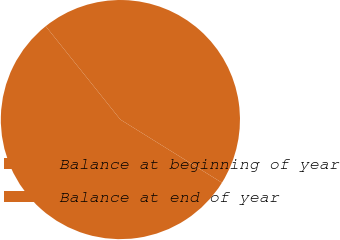Convert chart to OTSL. <chart><loc_0><loc_0><loc_500><loc_500><pie_chart><fcel>Balance at beginning of year<fcel>Balance at end of year<nl><fcel>44.59%<fcel>55.41%<nl></chart> 